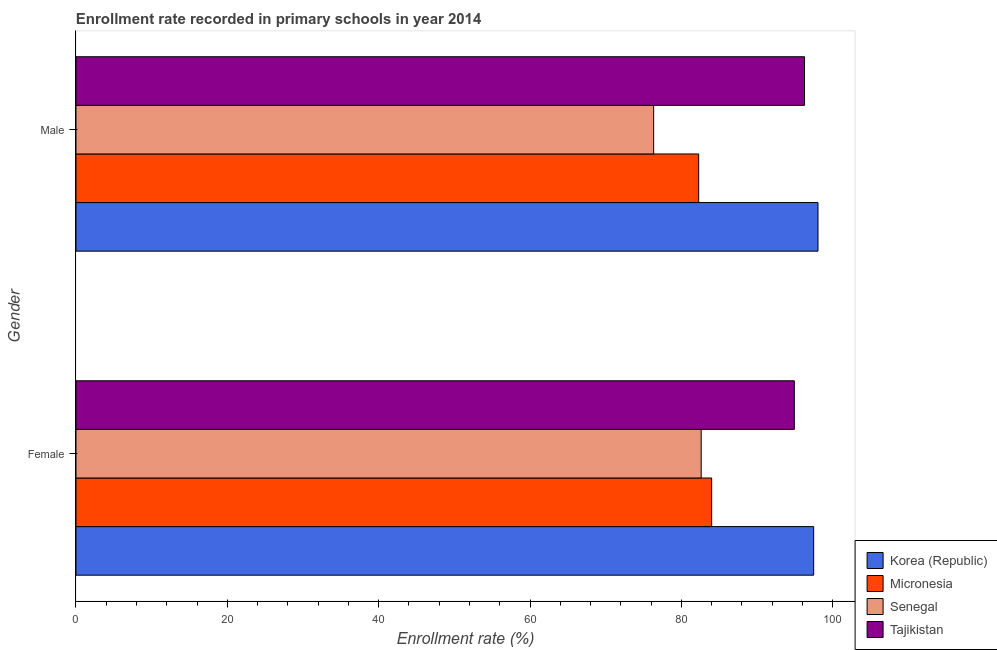How many groups of bars are there?
Your answer should be compact. 2. Are the number of bars on each tick of the Y-axis equal?
Offer a terse response. Yes. What is the enrollment rate of male students in Micronesia?
Ensure brevity in your answer.  82.29. Across all countries, what is the maximum enrollment rate of female students?
Ensure brevity in your answer.  97.49. Across all countries, what is the minimum enrollment rate of female students?
Keep it short and to the point. 82.63. In which country was the enrollment rate of male students maximum?
Keep it short and to the point. Korea (Republic). In which country was the enrollment rate of female students minimum?
Offer a terse response. Senegal. What is the total enrollment rate of female students in the graph?
Your answer should be very brief. 359.06. What is the difference between the enrollment rate of female students in Micronesia and that in Senegal?
Make the answer very short. 1.38. What is the difference between the enrollment rate of male students in Senegal and the enrollment rate of female students in Korea (Republic)?
Make the answer very short. -21.15. What is the average enrollment rate of male students per country?
Offer a terse response. 88.25. What is the difference between the enrollment rate of male students and enrollment rate of female students in Micronesia?
Your answer should be very brief. -1.72. What is the ratio of the enrollment rate of male students in Senegal to that in Korea (Republic)?
Your answer should be very brief. 0.78. Is the enrollment rate of female students in Tajikistan less than that in Senegal?
Provide a succinct answer. No. In how many countries, is the enrollment rate of male students greater than the average enrollment rate of male students taken over all countries?
Make the answer very short. 2. What does the 3rd bar from the top in Male represents?
Provide a short and direct response. Micronesia. What does the 3rd bar from the bottom in Male represents?
Make the answer very short. Senegal. Are all the bars in the graph horizontal?
Your answer should be very brief. Yes. How many countries are there in the graph?
Provide a succinct answer. 4. What is the difference between two consecutive major ticks on the X-axis?
Your answer should be compact. 20. Does the graph contain any zero values?
Provide a succinct answer. No. Does the graph contain grids?
Offer a very short reply. No. Where does the legend appear in the graph?
Make the answer very short. Bottom right. How many legend labels are there?
Offer a terse response. 4. What is the title of the graph?
Provide a short and direct response. Enrollment rate recorded in primary schools in year 2014. What is the label or title of the X-axis?
Offer a terse response. Enrollment rate (%). What is the label or title of the Y-axis?
Make the answer very short. Gender. What is the Enrollment rate (%) in Korea (Republic) in Female?
Provide a short and direct response. 97.49. What is the Enrollment rate (%) of Micronesia in Female?
Your response must be concise. 84.01. What is the Enrollment rate (%) in Senegal in Female?
Your answer should be compact. 82.63. What is the Enrollment rate (%) in Tajikistan in Female?
Give a very brief answer. 94.93. What is the Enrollment rate (%) in Korea (Republic) in Male?
Your answer should be compact. 98.06. What is the Enrollment rate (%) in Micronesia in Male?
Your response must be concise. 82.29. What is the Enrollment rate (%) in Senegal in Male?
Your response must be concise. 76.34. What is the Enrollment rate (%) in Tajikistan in Male?
Give a very brief answer. 96.28. Across all Gender, what is the maximum Enrollment rate (%) of Korea (Republic)?
Your answer should be very brief. 98.06. Across all Gender, what is the maximum Enrollment rate (%) of Micronesia?
Make the answer very short. 84.01. Across all Gender, what is the maximum Enrollment rate (%) of Senegal?
Provide a short and direct response. 82.63. Across all Gender, what is the maximum Enrollment rate (%) in Tajikistan?
Make the answer very short. 96.28. Across all Gender, what is the minimum Enrollment rate (%) of Korea (Republic)?
Make the answer very short. 97.49. Across all Gender, what is the minimum Enrollment rate (%) of Micronesia?
Provide a short and direct response. 82.29. Across all Gender, what is the minimum Enrollment rate (%) in Senegal?
Provide a succinct answer. 76.34. Across all Gender, what is the minimum Enrollment rate (%) in Tajikistan?
Your response must be concise. 94.93. What is the total Enrollment rate (%) of Korea (Republic) in the graph?
Offer a very short reply. 195.55. What is the total Enrollment rate (%) of Micronesia in the graph?
Make the answer very short. 166.3. What is the total Enrollment rate (%) in Senegal in the graph?
Your answer should be very brief. 158.97. What is the total Enrollment rate (%) of Tajikistan in the graph?
Your response must be concise. 191.22. What is the difference between the Enrollment rate (%) of Korea (Republic) in Female and that in Male?
Make the answer very short. -0.57. What is the difference between the Enrollment rate (%) in Micronesia in Female and that in Male?
Offer a terse response. 1.72. What is the difference between the Enrollment rate (%) of Senegal in Female and that in Male?
Offer a terse response. 6.28. What is the difference between the Enrollment rate (%) of Tajikistan in Female and that in Male?
Provide a short and direct response. -1.35. What is the difference between the Enrollment rate (%) of Korea (Republic) in Female and the Enrollment rate (%) of Micronesia in Male?
Provide a succinct answer. 15.2. What is the difference between the Enrollment rate (%) of Korea (Republic) in Female and the Enrollment rate (%) of Senegal in Male?
Your response must be concise. 21.15. What is the difference between the Enrollment rate (%) of Korea (Republic) in Female and the Enrollment rate (%) of Tajikistan in Male?
Your response must be concise. 1.21. What is the difference between the Enrollment rate (%) of Micronesia in Female and the Enrollment rate (%) of Senegal in Male?
Provide a succinct answer. 7.67. What is the difference between the Enrollment rate (%) in Micronesia in Female and the Enrollment rate (%) in Tajikistan in Male?
Your response must be concise. -12.27. What is the difference between the Enrollment rate (%) in Senegal in Female and the Enrollment rate (%) in Tajikistan in Male?
Make the answer very short. -13.66. What is the average Enrollment rate (%) of Korea (Republic) per Gender?
Provide a succinct answer. 97.78. What is the average Enrollment rate (%) in Micronesia per Gender?
Keep it short and to the point. 83.15. What is the average Enrollment rate (%) in Senegal per Gender?
Your answer should be compact. 79.48. What is the average Enrollment rate (%) of Tajikistan per Gender?
Keep it short and to the point. 95.61. What is the difference between the Enrollment rate (%) of Korea (Republic) and Enrollment rate (%) of Micronesia in Female?
Offer a terse response. 13.48. What is the difference between the Enrollment rate (%) of Korea (Republic) and Enrollment rate (%) of Senegal in Female?
Give a very brief answer. 14.87. What is the difference between the Enrollment rate (%) in Korea (Republic) and Enrollment rate (%) in Tajikistan in Female?
Offer a very short reply. 2.56. What is the difference between the Enrollment rate (%) of Micronesia and Enrollment rate (%) of Senegal in Female?
Make the answer very short. 1.38. What is the difference between the Enrollment rate (%) of Micronesia and Enrollment rate (%) of Tajikistan in Female?
Your answer should be very brief. -10.92. What is the difference between the Enrollment rate (%) of Senegal and Enrollment rate (%) of Tajikistan in Female?
Offer a terse response. -12.31. What is the difference between the Enrollment rate (%) of Korea (Republic) and Enrollment rate (%) of Micronesia in Male?
Provide a short and direct response. 15.77. What is the difference between the Enrollment rate (%) in Korea (Republic) and Enrollment rate (%) in Senegal in Male?
Make the answer very short. 21.72. What is the difference between the Enrollment rate (%) of Korea (Republic) and Enrollment rate (%) of Tajikistan in Male?
Offer a terse response. 1.78. What is the difference between the Enrollment rate (%) of Micronesia and Enrollment rate (%) of Senegal in Male?
Your answer should be compact. 5.95. What is the difference between the Enrollment rate (%) in Micronesia and Enrollment rate (%) in Tajikistan in Male?
Provide a short and direct response. -13.99. What is the difference between the Enrollment rate (%) of Senegal and Enrollment rate (%) of Tajikistan in Male?
Ensure brevity in your answer.  -19.94. What is the ratio of the Enrollment rate (%) of Micronesia in Female to that in Male?
Keep it short and to the point. 1.02. What is the ratio of the Enrollment rate (%) in Senegal in Female to that in Male?
Ensure brevity in your answer.  1.08. What is the difference between the highest and the second highest Enrollment rate (%) in Korea (Republic)?
Provide a succinct answer. 0.57. What is the difference between the highest and the second highest Enrollment rate (%) of Micronesia?
Keep it short and to the point. 1.72. What is the difference between the highest and the second highest Enrollment rate (%) in Senegal?
Provide a succinct answer. 6.28. What is the difference between the highest and the second highest Enrollment rate (%) in Tajikistan?
Offer a very short reply. 1.35. What is the difference between the highest and the lowest Enrollment rate (%) in Korea (Republic)?
Offer a very short reply. 0.57. What is the difference between the highest and the lowest Enrollment rate (%) in Micronesia?
Your response must be concise. 1.72. What is the difference between the highest and the lowest Enrollment rate (%) in Senegal?
Provide a succinct answer. 6.28. What is the difference between the highest and the lowest Enrollment rate (%) in Tajikistan?
Your answer should be compact. 1.35. 